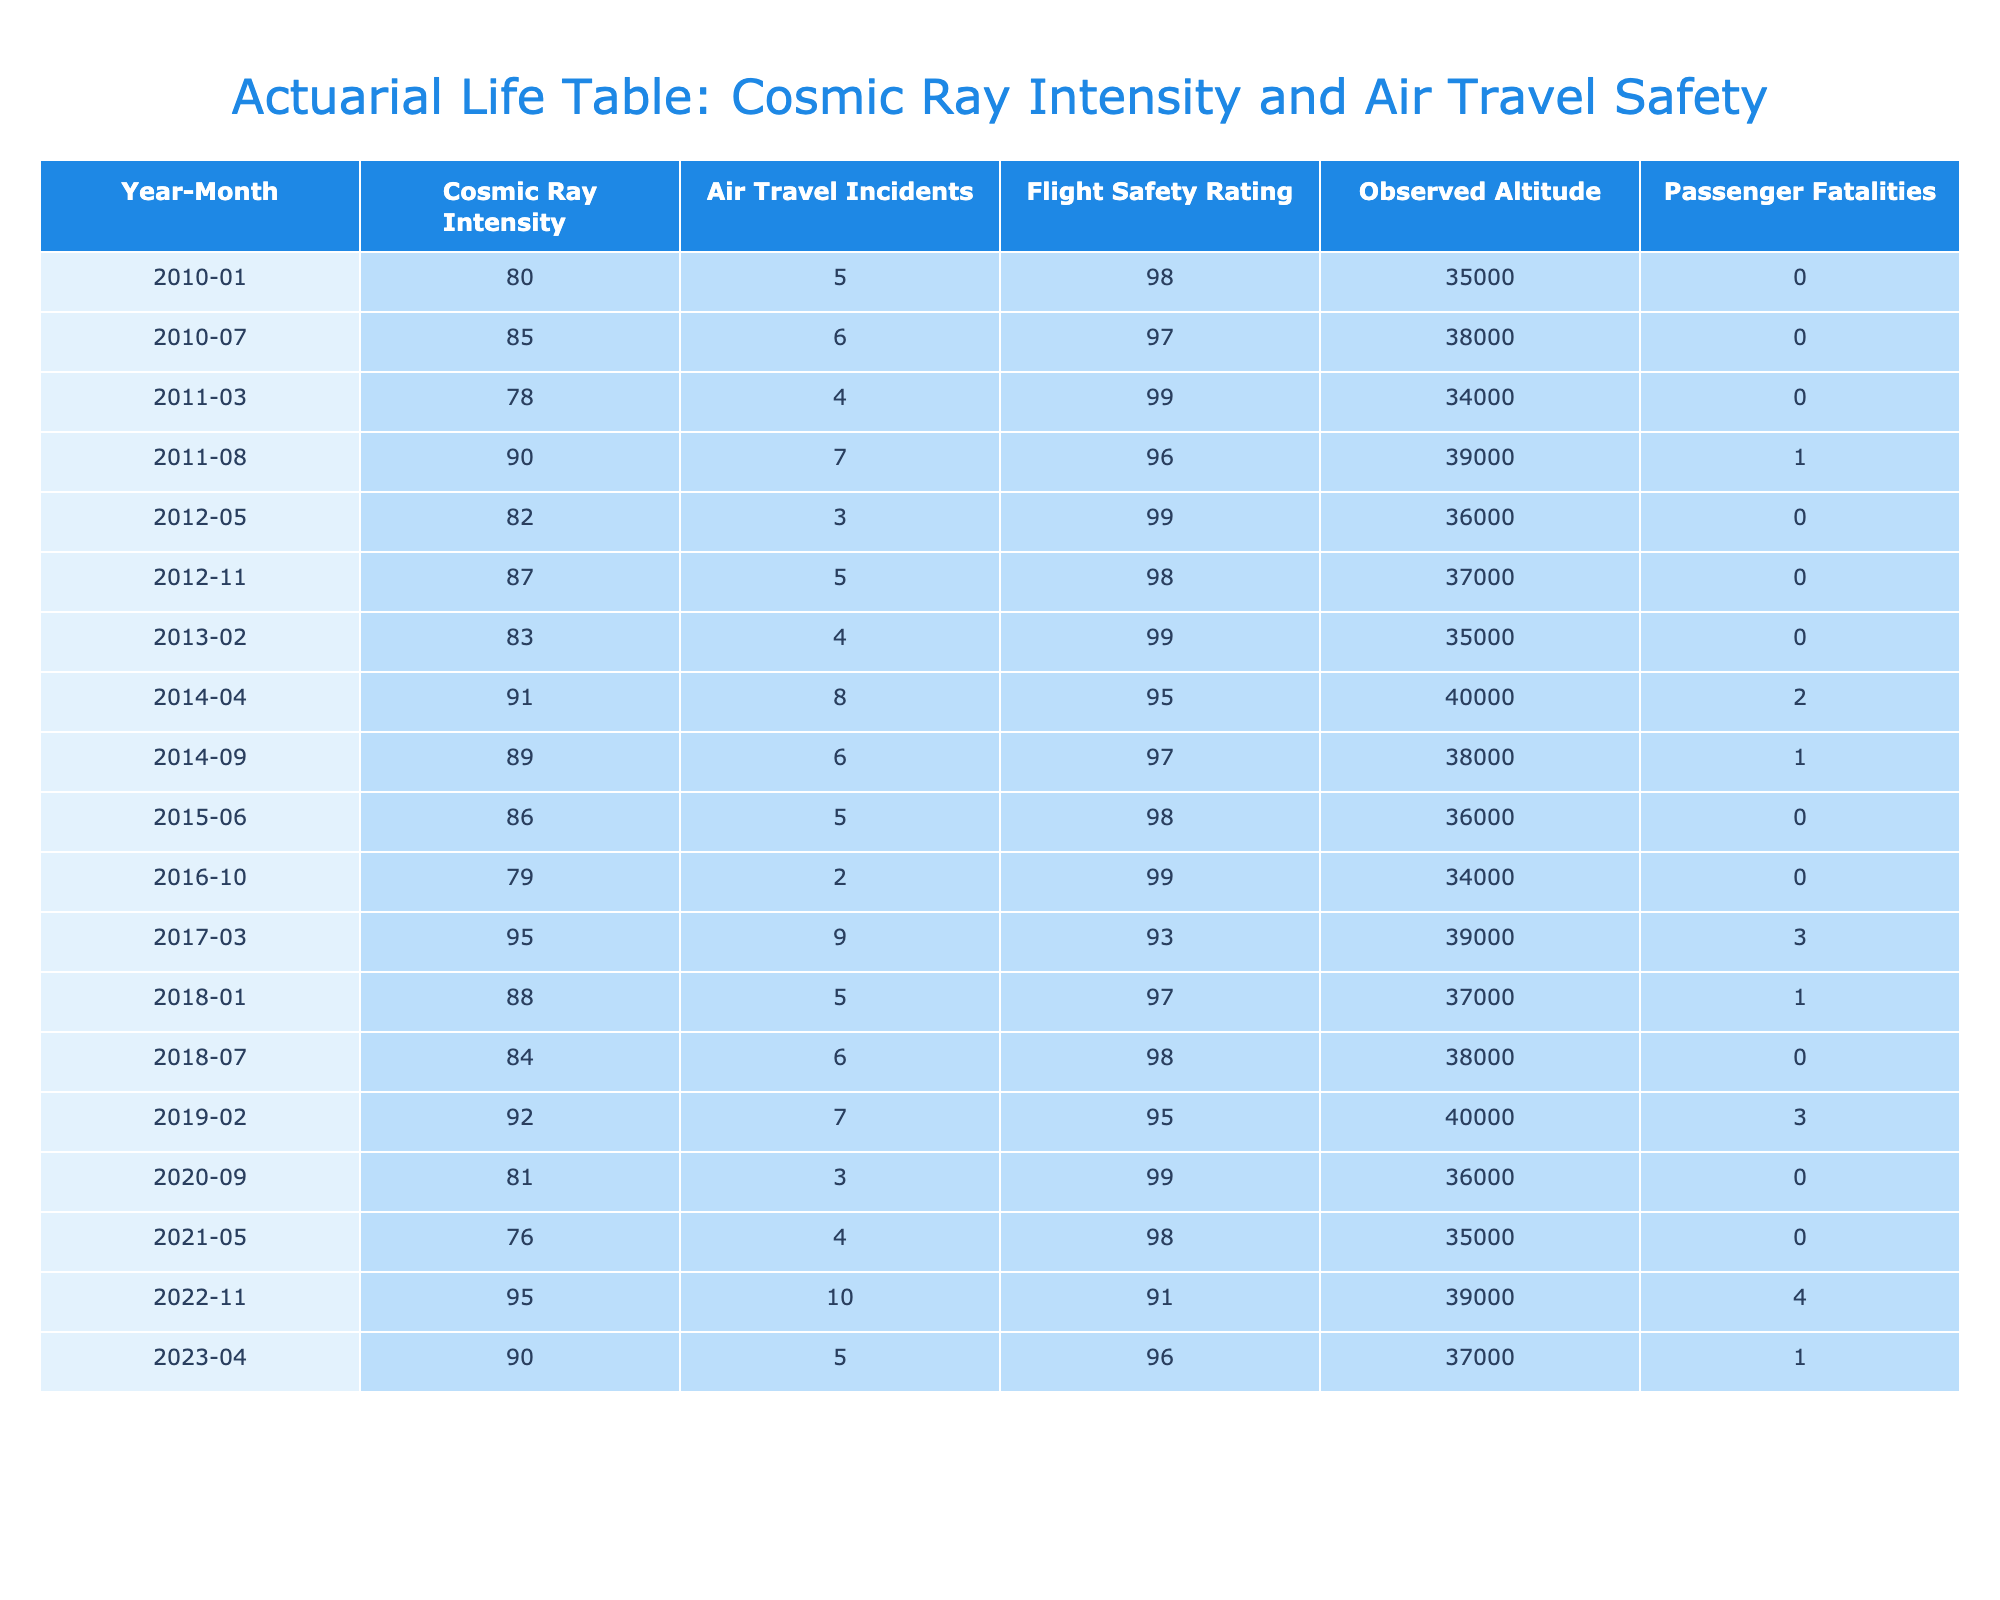What was the highest recorded cosmic ray intensity? The highest recorded cosmic ray intensity can be found by reviewing the 'Cosmic Ray Intensity' column. Scanning through the values, the maximum intensity listed is 95 in November 2022.
Answer: 95 In which month and year did the most air travel incidents occur? To find the month with the most air travel incidents, we look at the 'Air Travel Incidents' column and identify the maximum value, which is 10 occurring in November 2022.
Answer: November 2022 What is the average flight safety rating for the years 2010 to 2015? To calculate the average flight safety rating from 2010 to 2015, we sum the flight safety ratings for those years: (98 + 97 + 99 + 96 + 98 + 99) = 587, then divide by the number of entries (6), giving an average of 587/6 = 97.8333.
Answer: 97.83 Did any flights have passenger fatalities in 2015? By checking the 'Passenger Fatalities' column for the year 2015, we see that all values in that year are 0, indicating there were no fatalities.
Answer: No What is the total number of passenger fatalities recorded between 2010 and 2023? To find the total passenger fatalities, we sum the 'Passenger Fatalities' values from each row from 2010 to 2023: (0 + 0 + 0 + 1 + 0 + 0 + 0 + 2 + 1 + 0 + 0 + 0 + 3 + 1 + 0 + 3 + 0 + 0 + 4 + 1) = 16.
Answer: 16 In 2011, were there more air travel incidents or cosmic ray intensity? In 2011, the air travel incidents amounted to 4 (March) and 7 (August), totaling 11 incidents. The cosmic ray intensity values are 78 (March) and 90 (August). Here, we compare 11 to the maximum cosmic ray intensity of 90 obtained in August, so incidents were lower.
Answer: No 